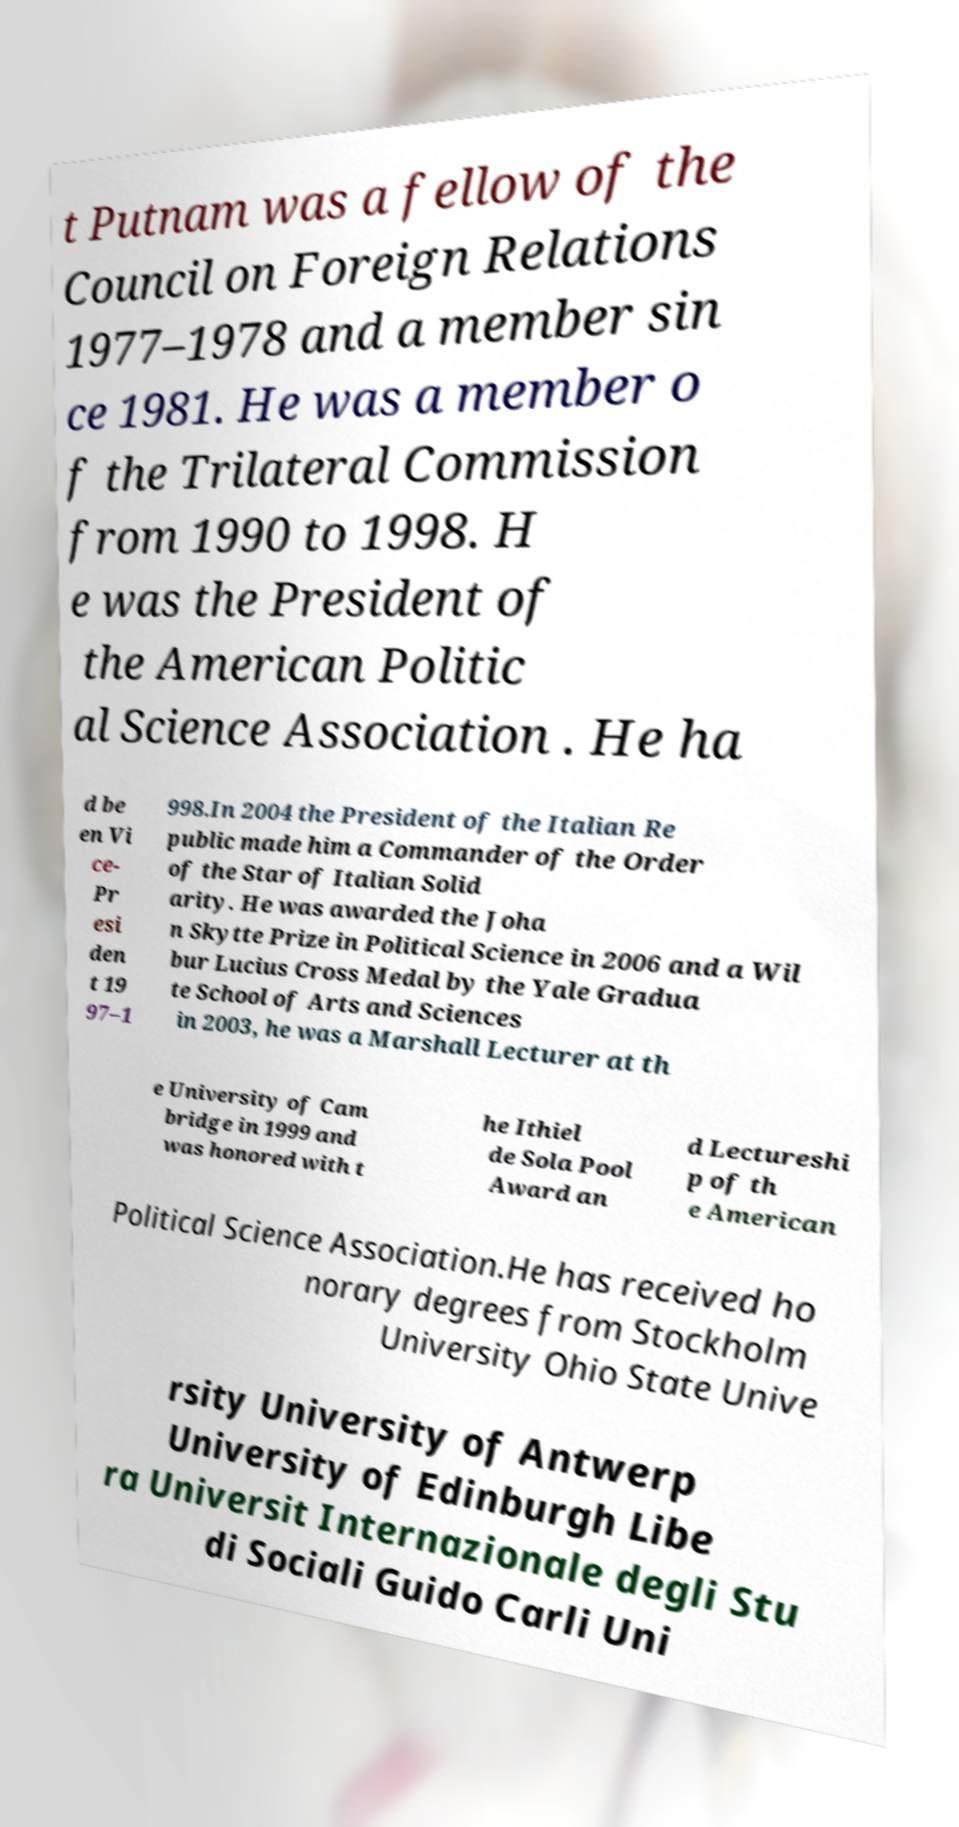Could you extract and type out the text from this image? t Putnam was a fellow of the Council on Foreign Relations 1977–1978 and a member sin ce 1981. He was a member o f the Trilateral Commission from 1990 to 1998. H e was the President of the American Politic al Science Association . He ha d be en Vi ce- Pr esi den t 19 97–1 998.In 2004 the President of the Italian Re public made him a Commander of the Order of the Star of Italian Solid arity. He was awarded the Joha n Skytte Prize in Political Science in 2006 and a Wil bur Lucius Cross Medal by the Yale Gradua te School of Arts and Sciences in 2003, he was a Marshall Lecturer at th e University of Cam bridge in 1999 and was honored with t he Ithiel de Sola Pool Award an d Lectureshi p of th e American Political Science Association.He has received ho norary degrees from Stockholm University Ohio State Unive rsity University of Antwerp University of Edinburgh Libe ra Universit Internazionale degli Stu di Sociali Guido Carli Uni 